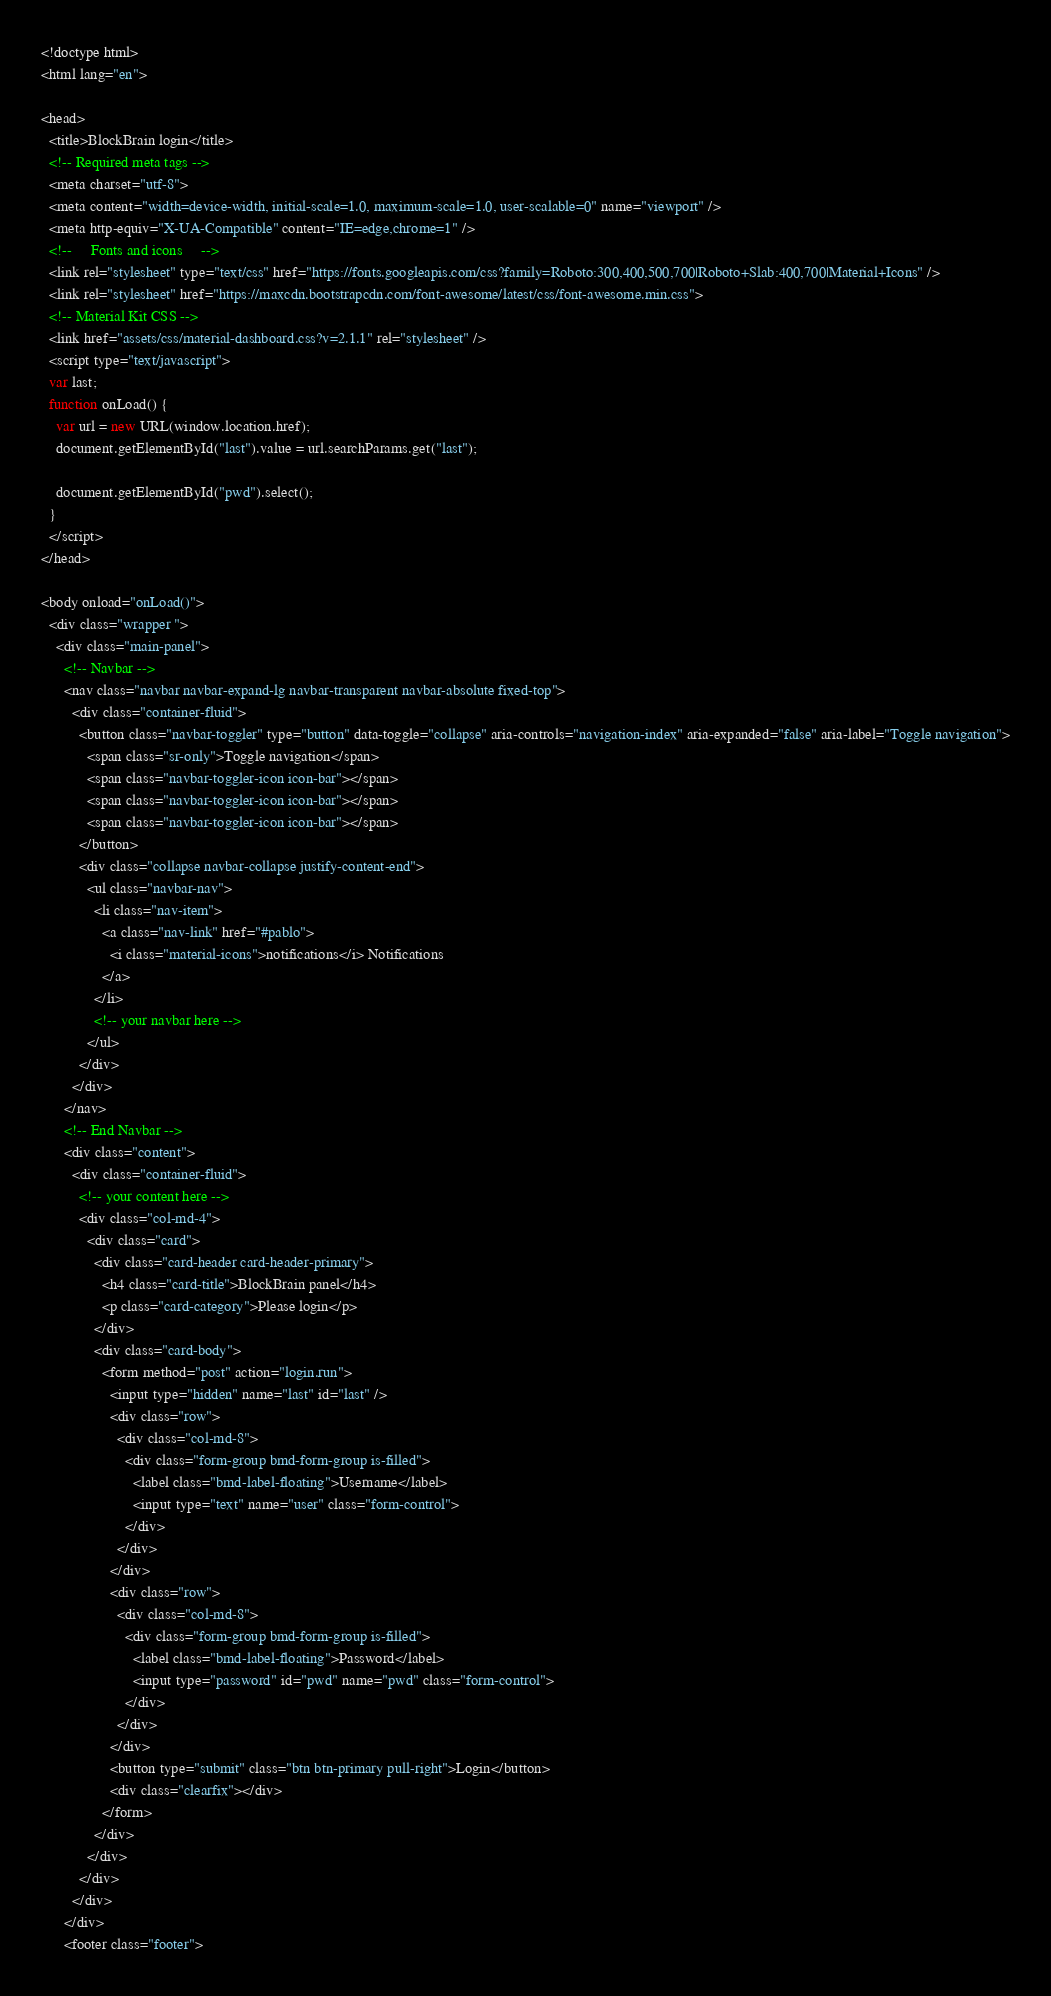<code> <loc_0><loc_0><loc_500><loc_500><_HTML_><!doctype html>
<html lang="en">

<head>
  <title>BlockBrain login</title>
  <!-- Required meta tags -->
  <meta charset="utf-8">
  <meta content="width=device-width, initial-scale=1.0, maximum-scale=1.0, user-scalable=0" name="viewport" />
  <meta http-equiv="X-UA-Compatible" content="IE=edge,chrome=1" />
  <!--     Fonts and icons     -->
  <link rel="stylesheet" type="text/css" href="https://fonts.googleapis.com/css?family=Roboto:300,400,500,700|Roboto+Slab:400,700|Material+Icons" />
  <link rel="stylesheet" href="https://maxcdn.bootstrapcdn.com/font-awesome/latest/css/font-awesome.min.css">
  <!-- Material Kit CSS -->
  <link href="assets/css/material-dashboard.css?v=2.1.1" rel="stylesheet" />
  <script type="text/javascript">
  var last;
  function onLoad() {
    var url = new URL(window.location.href);
    document.getElementById("last").value = url.searchParams.get("last");

    document.getElementById("pwd").select();
  }
  </script>
</head>

<body onload="onLoad()">
  <div class="wrapper ">
    <div class="main-panel">
      <!-- Navbar -->
      <nav class="navbar navbar-expand-lg navbar-transparent navbar-absolute fixed-top">
        <div class="container-fluid">
          <button class="navbar-toggler" type="button" data-toggle="collapse" aria-controls="navigation-index" aria-expanded="false" aria-label="Toggle navigation">
            <span class="sr-only">Toggle navigation</span>
            <span class="navbar-toggler-icon icon-bar"></span>
            <span class="navbar-toggler-icon icon-bar"></span>
            <span class="navbar-toggler-icon icon-bar"></span>
          </button>
          <div class="collapse navbar-collapse justify-content-end">
            <ul class="navbar-nav">
              <li class="nav-item">
                <a class="nav-link" href="#pablo">
                  <i class="material-icons">notifications</i> Notifications
                </a>
              </li>
              <!-- your navbar here -->
            </ul>
          </div>
        </div>
      </nav>
      <!-- End Navbar -->
      <div class="content">
        <div class="container-fluid">
          <!-- your content here -->
          <div class="col-md-4">
            <div class="card">
              <div class="card-header card-header-primary">
                <h4 class="card-title">BlockBrain panel</h4>
                <p class="card-category">Please login</p>
              </div>
              <div class="card-body">
                <form method="post" action="login.run">
                  <input type="hidden" name="last" id="last" />
                  <div class="row">
                    <div class="col-md-8">
                      <div class="form-group bmd-form-group is-filled">
                        <label class="bmd-label-floating">Username</label>
                        <input type="text" name="user" class="form-control">
                      </div>
                    </div>
                  </div>
                  <div class="row">
                    <div class="col-md-8">
                      <div class="form-group bmd-form-group is-filled">
                        <label class="bmd-label-floating">Password</label>
                        <input type="password" id="pwd" name="pwd" class="form-control">
                      </div>
                    </div>
                  </div>
                  <button type="submit" class="btn btn-primary pull-right">Login</button>
                  <div class="clearfix"></div>
                </form>
              </div>
            </div>
          </div>
        </div>
      </div>
      <footer class="footer"></code> 